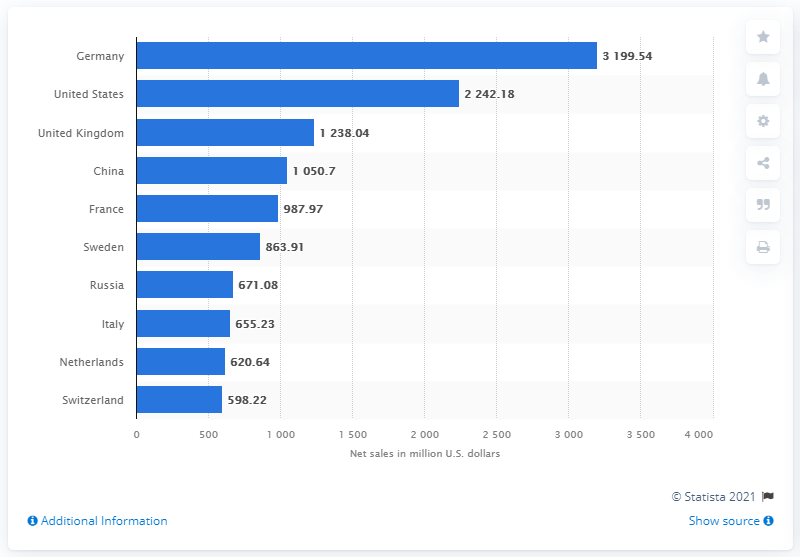Give some essential details in this illustration. In the fiscal year 2020, the net sales of the H&M Group in the United States were 2242.18. 